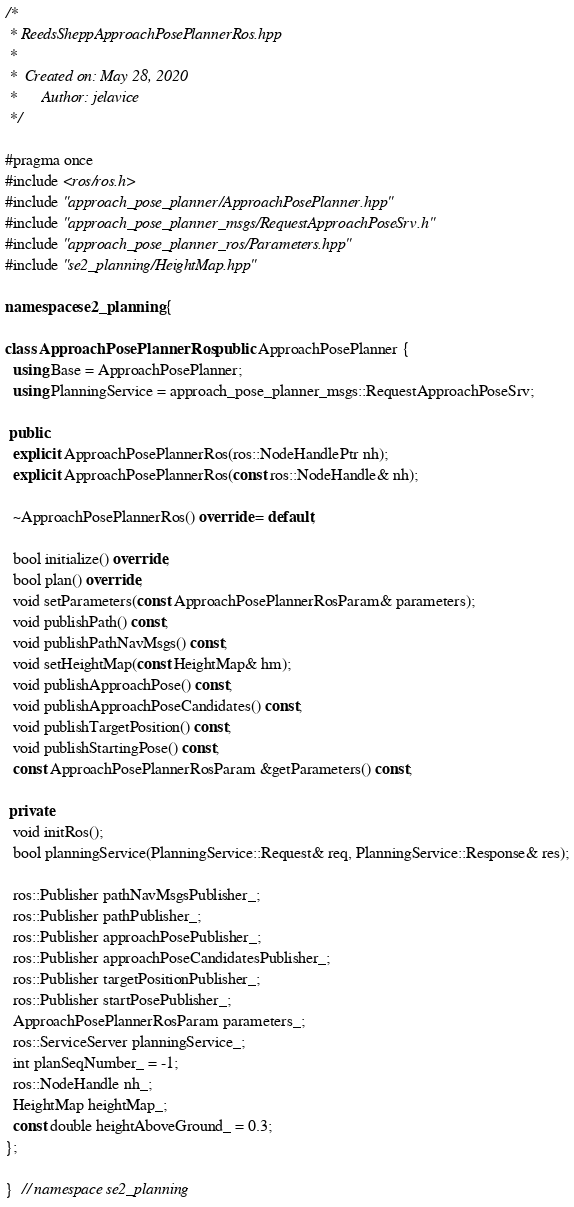<code> <loc_0><loc_0><loc_500><loc_500><_C++_>/*
 * ReedsSheppApproachPosePlannerRos.hpp
 *
 *  Created on: May 28, 2020
 *      Author: jelavice
 */

#pragma once
#include <ros/ros.h>
#include "approach_pose_planner/ApproachPosePlanner.hpp"
#include "approach_pose_planner_msgs/RequestApproachPoseSrv.h"
#include "approach_pose_planner_ros/Parameters.hpp"
#include "se2_planning/HeightMap.hpp"

namespace se2_planning {

class ApproachPosePlannerRos : public ApproachPosePlanner {
  using Base = ApproachPosePlanner;
  using PlanningService = approach_pose_planner_msgs::RequestApproachPoseSrv;

 public:
  explicit ApproachPosePlannerRos(ros::NodeHandlePtr nh);
  explicit ApproachPosePlannerRos(const ros::NodeHandle& nh);

  ~ApproachPosePlannerRos() override = default;

  bool initialize() override;
  bool plan() override;
  void setParameters(const ApproachPosePlannerRosParam& parameters);
  void publishPath() const;
  void publishPathNavMsgs() const;
  void setHeightMap(const HeightMap& hm);
  void publishApproachPose() const;
  void publishApproachPoseCandidates() const;
  void publishTargetPosition() const;
  void publishStartingPose() const;
  const ApproachPosePlannerRosParam &getParameters() const;

 private:
  void initRos();
  bool planningService(PlanningService::Request& req, PlanningService::Response& res);

  ros::Publisher pathNavMsgsPublisher_;
  ros::Publisher pathPublisher_;
  ros::Publisher approachPosePublisher_;
  ros::Publisher approachPoseCandidatesPublisher_;
  ros::Publisher targetPositionPublisher_;
  ros::Publisher startPosePublisher_;
  ApproachPosePlannerRosParam parameters_;
  ros::ServiceServer planningService_;
  int planSeqNumber_ = -1;
  ros::NodeHandle nh_;
  HeightMap heightMap_;
  const double heightAboveGround_ = 0.3;
};

}  // namespace se2_planning
</code> 